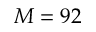Convert formula to latex. <formula><loc_0><loc_0><loc_500><loc_500>M = 9 2</formula> 